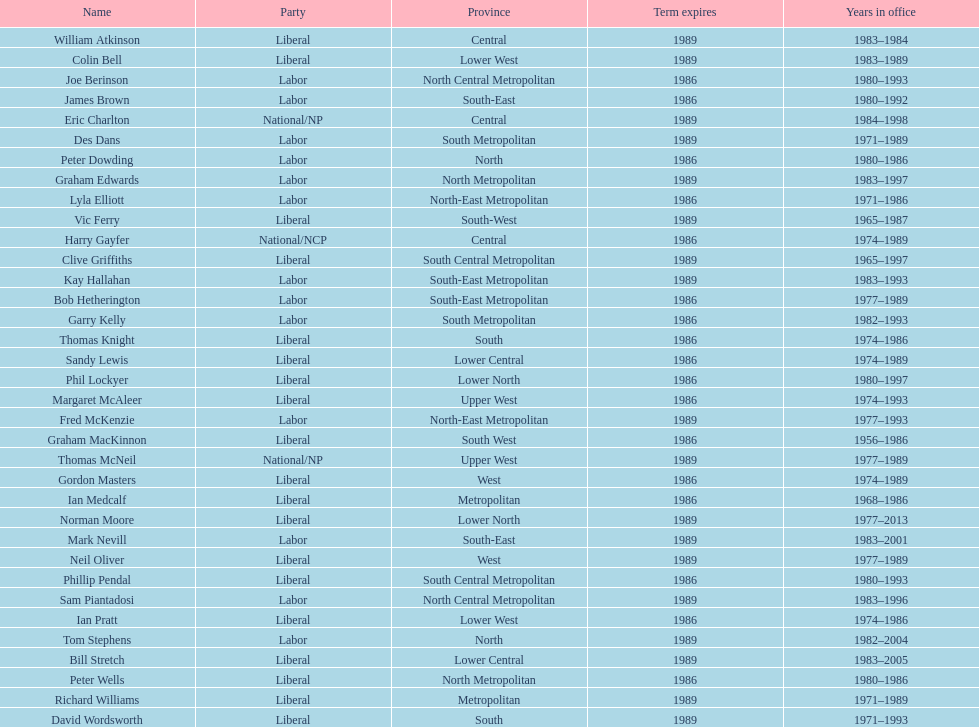How many members were party of lower west province? 2. 